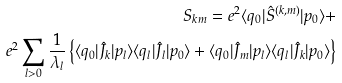Convert formula to latex. <formula><loc_0><loc_0><loc_500><loc_500>S _ { k m } = e ^ { 2 } \langle q _ { 0 } | \hat { S } ^ { ( k , m ) } | p _ { 0 } \rangle + \\ e ^ { 2 } \sum _ { l > 0 } \frac { 1 } { \lambda _ { l } } \left \{ \langle q _ { 0 } | \hat { J } _ { k } | p _ { l } \rangle \langle q _ { l } | \hat { J } _ { l } | p _ { 0 } \rangle + \langle q _ { 0 } | \hat { J } _ { m } | p _ { l } \rangle \langle q _ { l } | \hat { J } _ { k } | p _ { 0 } \rangle \right \}</formula> 